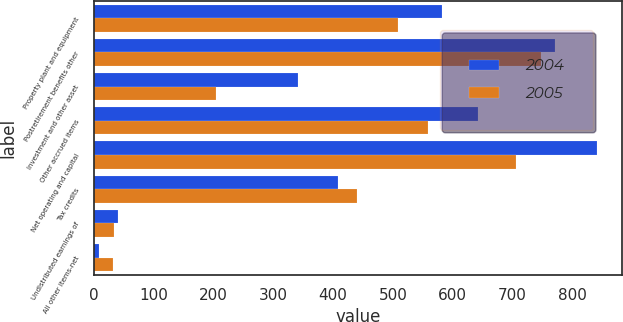<chart> <loc_0><loc_0><loc_500><loc_500><stacked_bar_chart><ecel><fcel>Property plant and equipment<fcel>Postretirement benefits other<fcel>Investment and other asset<fcel>Other accrued items<fcel>Net operating and capital<fcel>Tax credits<fcel>Undistributed earnings of<fcel>All other items-net<nl><fcel>2004<fcel>582<fcel>771<fcel>342<fcel>642<fcel>841<fcel>408<fcel>40<fcel>8<nl><fcel>2005<fcel>509<fcel>748<fcel>205<fcel>558<fcel>706<fcel>440<fcel>34<fcel>33<nl></chart> 